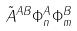<formula> <loc_0><loc_0><loc_500><loc_500>\tilde { A } ^ { A B } \Phi _ { n } ^ { A } \Phi _ { m } ^ { B }</formula> 